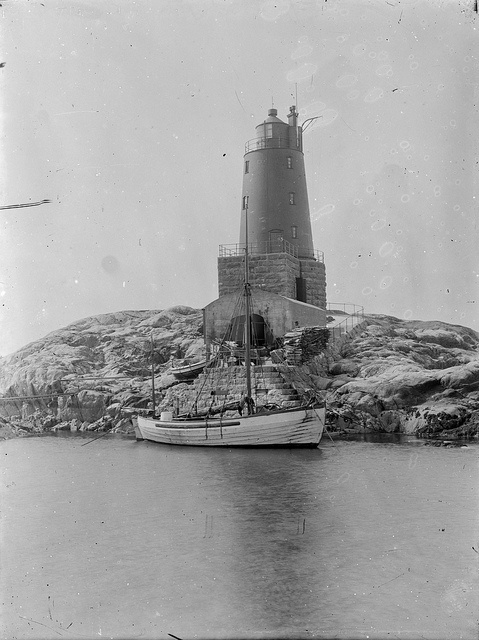Describe the objects in this image and their specific colors. I can see a boat in darkgray, gray, black, and lightgray tones in this image. 